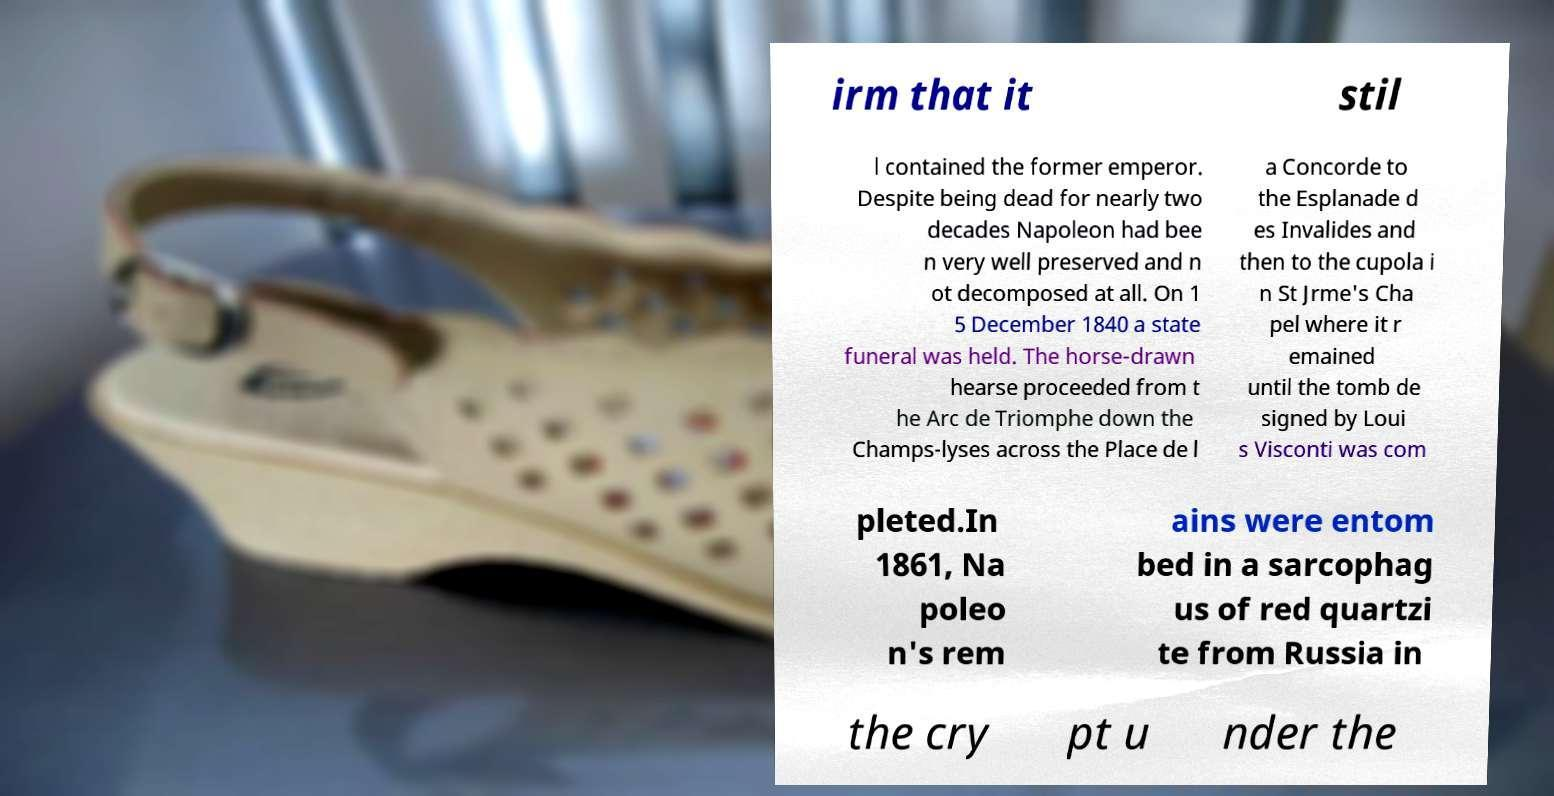For documentation purposes, I need the text within this image transcribed. Could you provide that? irm that it stil l contained the former emperor. Despite being dead for nearly two decades Napoleon had bee n very well preserved and n ot decomposed at all. On 1 5 December 1840 a state funeral was held. The horse-drawn hearse proceeded from t he Arc de Triomphe down the Champs-lyses across the Place de l a Concorde to the Esplanade d es Invalides and then to the cupola i n St Jrme's Cha pel where it r emained until the tomb de signed by Loui s Visconti was com pleted.In 1861, Na poleo n's rem ains were entom bed in a sarcophag us of red quartzi te from Russia in the cry pt u nder the 